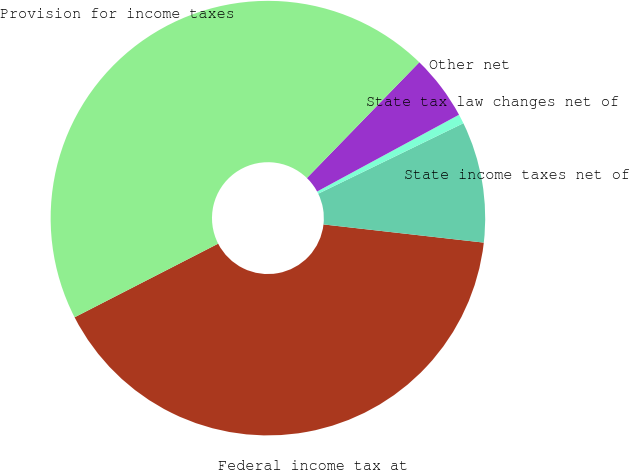Convert chart. <chart><loc_0><loc_0><loc_500><loc_500><pie_chart><fcel>Federal income tax at<fcel>State income taxes net of<fcel>State tax law changes net of<fcel>Other net<fcel>Provision for income taxes<nl><fcel>40.66%<fcel>8.99%<fcel>0.7%<fcel>4.84%<fcel>44.81%<nl></chart> 